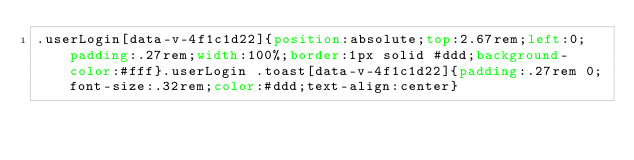Convert code to text. <code><loc_0><loc_0><loc_500><loc_500><_CSS_>.userLogin[data-v-4f1c1d22]{position:absolute;top:2.67rem;left:0;padding:.27rem;width:100%;border:1px solid #ddd;background-color:#fff}.userLogin .toast[data-v-4f1c1d22]{padding:.27rem 0;font-size:.32rem;color:#ddd;text-align:center}</code> 